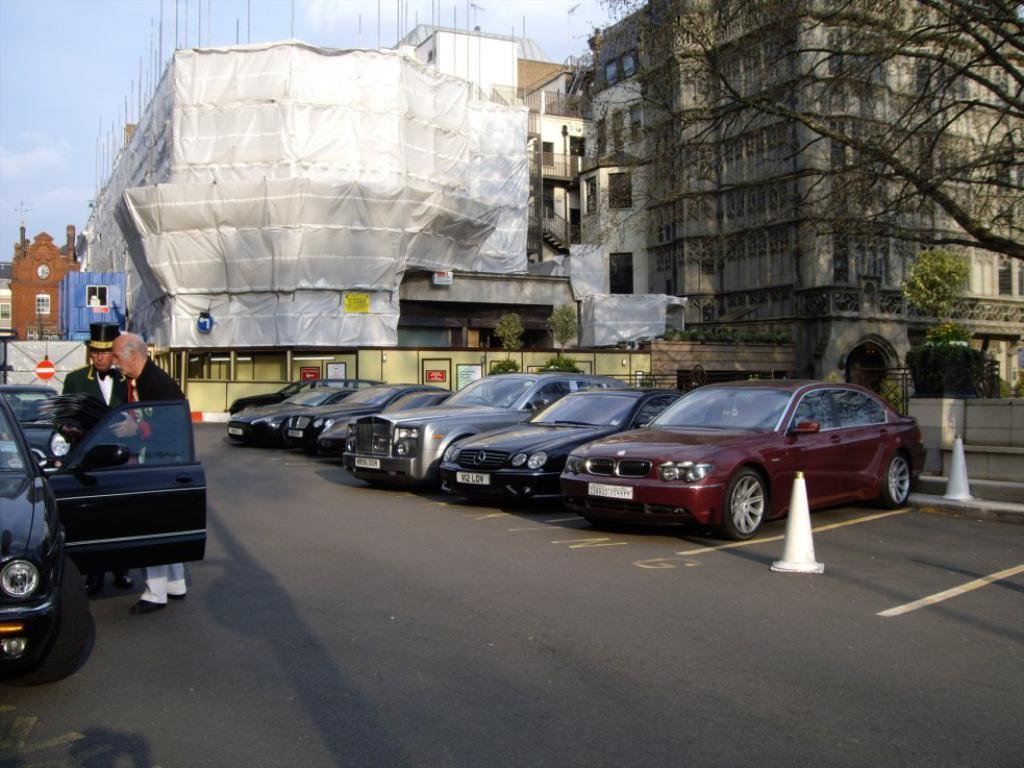What type of structures can be seen in the image? There are buildings with windows in the image. What else can be seen in the image besides buildings? There are plants, sign boards, and vehicles present in the image. What are the people in the image doing? Two people are standing beside a vehicle in the image. Can you tell me how many minutes it takes for the ghost to drive through the image? There is no ghost or driving present in the image, so it is not possible to answer that question. 